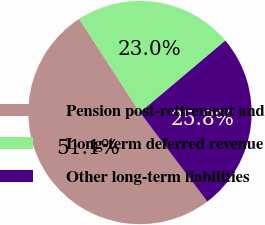<chart> <loc_0><loc_0><loc_500><loc_500><pie_chart><fcel>Pension post-retirement and<fcel>Long-term deferred revenue<fcel>Other long-term liabilities<nl><fcel>51.14%<fcel>23.03%<fcel>25.84%<nl></chart> 